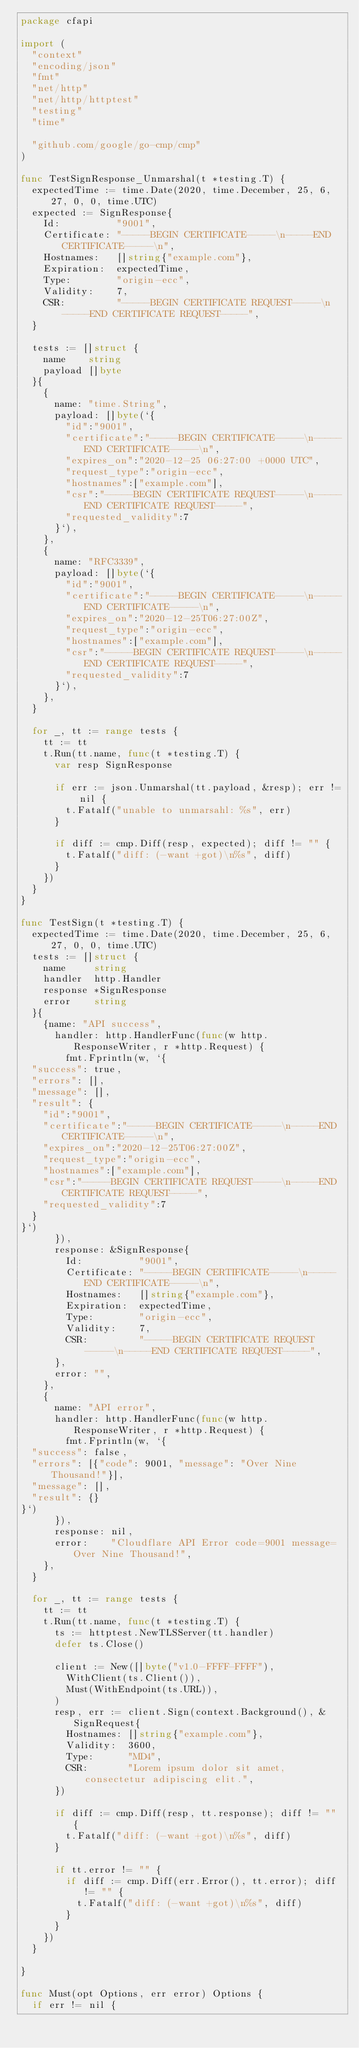<code> <loc_0><loc_0><loc_500><loc_500><_Go_>package cfapi

import (
	"context"
	"encoding/json"
	"fmt"
	"net/http"
	"net/http/httptest"
	"testing"
	"time"

	"github.com/google/go-cmp/cmp"
)

func TestSignResponse_Unmarshal(t *testing.T) {
	expectedTime := time.Date(2020, time.December, 25, 6, 27, 0, 0, time.UTC)
	expected := SignResponse{
		Id:          "9001",
		Certificate: "-----BEGIN CERTIFICATE-----\n-----END CERTIFICATE-----\n",
		Hostnames:   []string{"example.com"},
		Expiration:  expectedTime,
		Type:        "origin-ecc",
		Validity:    7,
		CSR:         "-----BEGIN CERTIFICATE REQUEST-----\n-----END CERTIFICATE REQUEST-----",
	}

	tests := []struct {
		name    string
		payload []byte
	}{
		{
			name: "time.String",
			payload: []byte(`{
        "id":"9001",
        "certificate":"-----BEGIN CERTIFICATE-----\n-----END CERTIFICATE-----\n",
        "expires_on":"2020-12-25 06:27:00 +0000 UTC",
        "request_type":"origin-ecc",
        "hostnames":["example.com"],
        "csr":"-----BEGIN CERTIFICATE REQUEST-----\n-----END CERTIFICATE REQUEST-----",
        "requested_validity":7
      }`),
		},
		{
			name: "RFC3339",
			payload: []byte(`{
        "id":"9001",
        "certificate":"-----BEGIN CERTIFICATE-----\n-----END CERTIFICATE-----\n",
        "expires_on":"2020-12-25T06:27:00Z",
        "request_type":"origin-ecc",
        "hostnames":["example.com"],
        "csr":"-----BEGIN CERTIFICATE REQUEST-----\n-----END CERTIFICATE REQUEST-----",
        "requested_validity":7
      }`),
		},
	}

	for _, tt := range tests {
		tt := tt
		t.Run(tt.name, func(t *testing.T) {
			var resp SignResponse

			if err := json.Unmarshal(tt.payload, &resp); err != nil {
				t.Fatalf("unable to unmarsahl: %s", err)
			}

			if diff := cmp.Diff(resp, expected); diff != "" {
				t.Fatalf("diff: (-want +got)\n%s", diff)
			}
		})
	}
}

func TestSign(t *testing.T) {
	expectedTime := time.Date(2020, time.December, 25, 6, 27, 0, 0, time.UTC)
	tests := []struct {
		name     string
		handler  http.Handler
		response *SignResponse
		error    string
	}{
		{name: "API success",
			handler: http.HandlerFunc(func(w http.ResponseWriter, r *http.Request) {
				fmt.Fprintln(w, `{
	"success": true,
	"errors": [],
	"message": [],
	"result": {
		"id":"9001",
		"certificate":"-----BEGIN CERTIFICATE-----\n-----END CERTIFICATE-----\n",
		"expires_on":"2020-12-25T06:27:00Z",
		"request_type":"origin-ecc",
		"hostnames":["example.com"],
		"csr":"-----BEGIN CERTIFICATE REQUEST-----\n-----END CERTIFICATE REQUEST-----",
		"requested_validity":7
	}
}`)
			}),
			response: &SignResponse{
				Id:          "9001",
				Certificate: "-----BEGIN CERTIFICATE-----\n-----END CERTIFICATE-----\n",
				Hostnames:   []string{"example.com"},
				Expiration:  expectedTime,
				Type:        "origin-ecc",
				Validity:    7,
				CSR:         "-----BEGIN CERTIFICATE REQUEST-----\n-----END CERTIFICATE REQUEST-----",
			},
			error: "",
		},
		{
			name: "API error",
			handler: http.HandlerFunc(func(w http.ResponseWriter, r *http.Request) {
				fmt.Fprintln(w, `{
	"success": false,
	"errors": [{"code": 9001, "message": "Over Nine Thousand!"}],
	"message": [],
	"result": {}
}`)
			}),
			response: nil,
			error:    "Cloudflare API Error code=9001 message=Over Nine Thousand!",
		},
	}

	for _, tt := range tests {
		tt := tt
		t.Run(tt.name, func(t *testing.T) {
			ts := httptest.NewTLSServer(tt.handler)
			defer ts.Close()

			client := New([]byte("v1.0-FFFF-FFFF"),
				WithClient(ts.Client()),
				Must(WithEndpoint(ts.URL)),
			)
			resp, err := client.Sign(context.Background(), &SignRequest{
				Hostnames: []string{"example.com"},
				Validity:  3600,
				Type:      "MD4",
				CSR:       "Lorem ipsum dolor sit amet, consectetur adipiscing elit.",
			})

			if diff := cmp.Diff(resp, tt.response); diff != "" {
				t.Fatalf("diff: (-want +got)\n%s", diff)
			}

			if tt.error != "" {
				if diff := cmp.Diff(err.Error(), tt.error); diff != "" {
					t.Fatalf("diff: (-want +got)\n%s", diff)
				}
			}
		})
	}

}

func Must(opt Options, err error) Options {
	if err != nil {</code> 